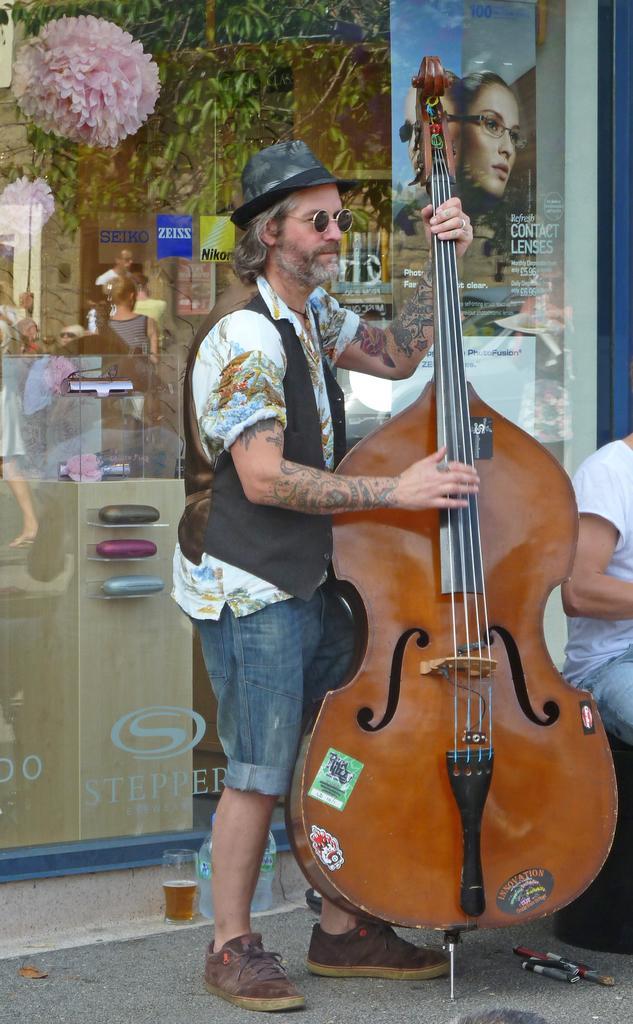In one or two sentences, can you explain what this image depicts? In this image I can see a person is standing on the floor and holding a guitar in hand. In the background I can see a crowd, posters, flowers and trees. On the right I can see a person is sitting. This image is taken in a hall. 